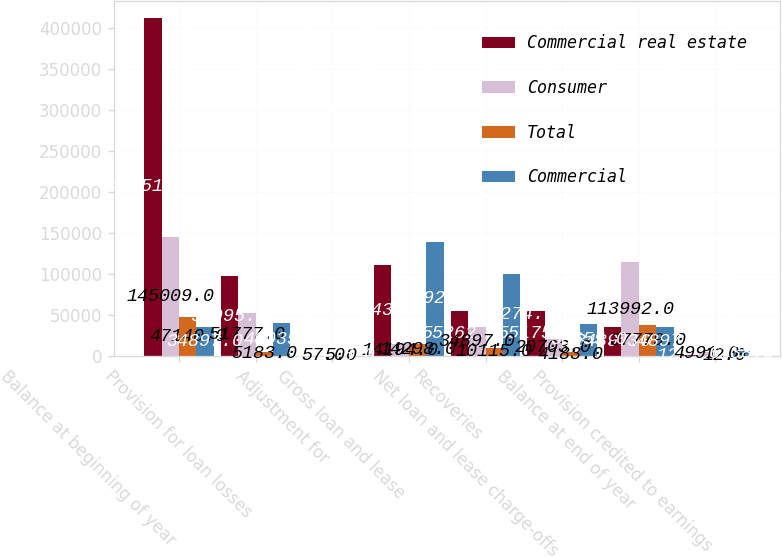Convert chart to OTSL. <chart><loc_0><loc_0><loc_500><loc_500><stacked_bar_chart><ecel><fcel>Balance at beginning of year<fcel>Provision for loan losses<fcel>Adjustment for<fcel>Gross loan and lease<fcel>Recoveries<fcel>Net loan and lease charge-offs<fcel>Balance at end of year<fcel>Provision credited to earnings<nl><fcel>Commercial real estate<fcel>412514<fcel>96995<fcel>57<fcel>110437<fcel>55262<fcel>55175<fcel>34897<fcel>1235<nl><fcel>Consumer<fcel>145009<fcel>51777<fcel>57<fcel>14194<fcel>34897<fcel>20703<fcel>113992<fcel>4991<nl><fcel>Total<fcel>47140<fcel>5183<fcel>5<fcel>14298<fcel>10115<fcel>4183<fcel>37779<fcel>12<nl><fcel>Commercial<fcel>34897<fcel>40035<fcel>5<fcel>138929<fcel>100274<fcel>38655<fcel>34897<fcel>6238<nl></chart> 